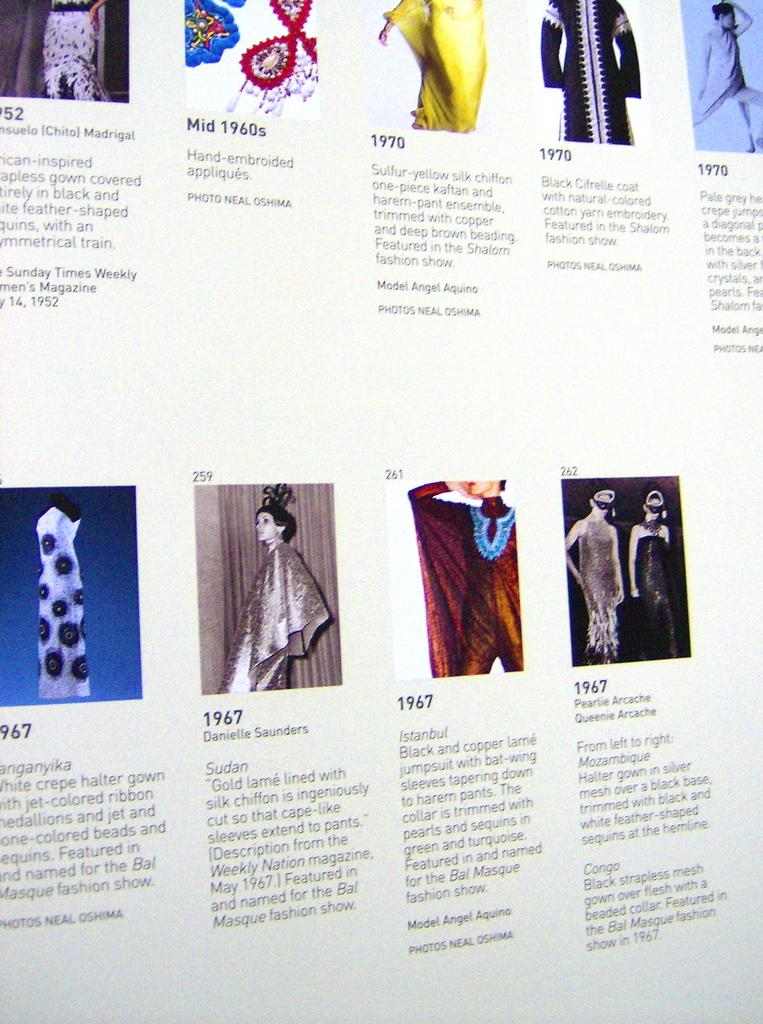What is the main object in the image? There is a screen in the image. What can be seen on the screen? There are people visible on the screen. What type of town is depicted on the screen? There is no town depicted on the screen; it shows people. What is the spoon used for in the image? There is no spoon present in the image. 